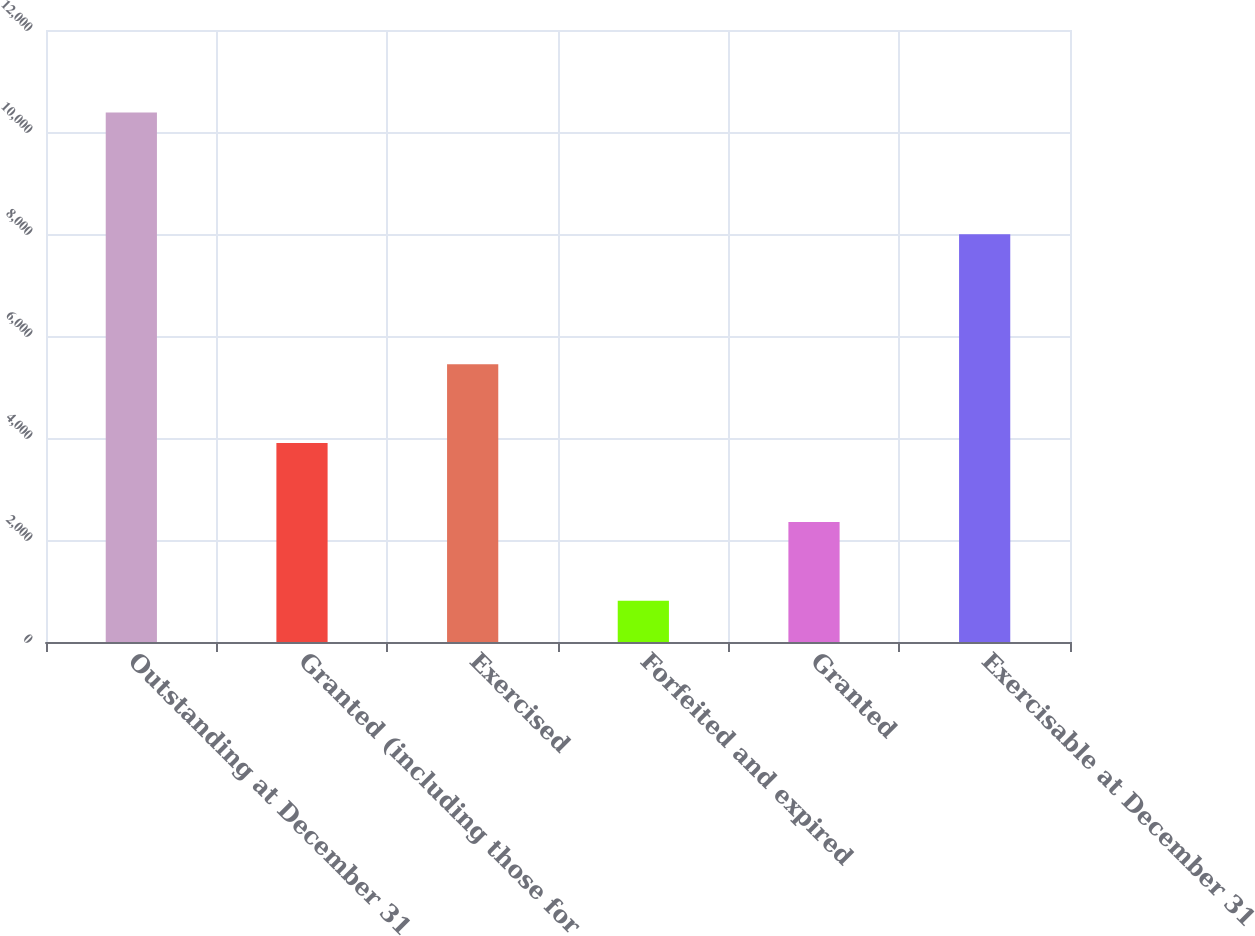Convert chart to OTSL. <chart><loc_0><loc_0><loc_500><loc_500><bar_chart><fcel>Outstanding at December 31<fcel>Granted (including those for<fcel>Exercised<fcel>Forfeited and expired<fcel>Granted<fcel>Exercisable at December 31<nl><fcel>10380<fcel>3901.6<fcel>5448.4<fcel>808<fcel>2354.8<fcel>7994<nl></chart> 